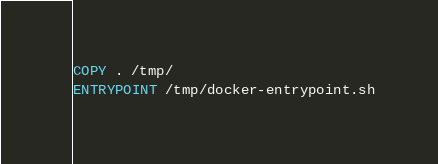Convert code to text. <code><loc_0><loc_0><loc_500><loc_500><_Dockerfile_>
COPY . /tmp/
ENTRYPOINT /tmp/docker-entrypoint.sh
</code> 